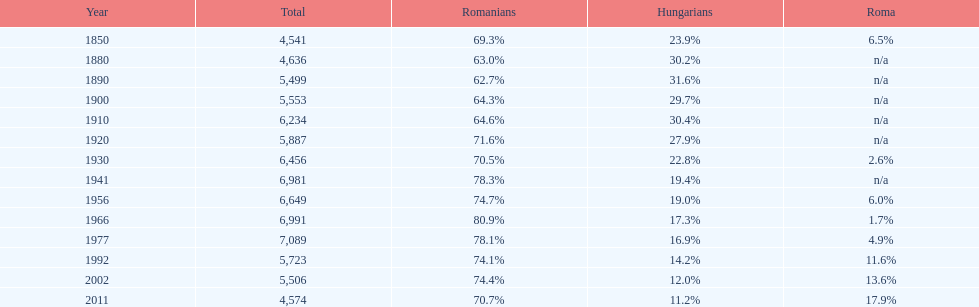How many instances were there when the overall population reached 6,000 or higher? 6. 